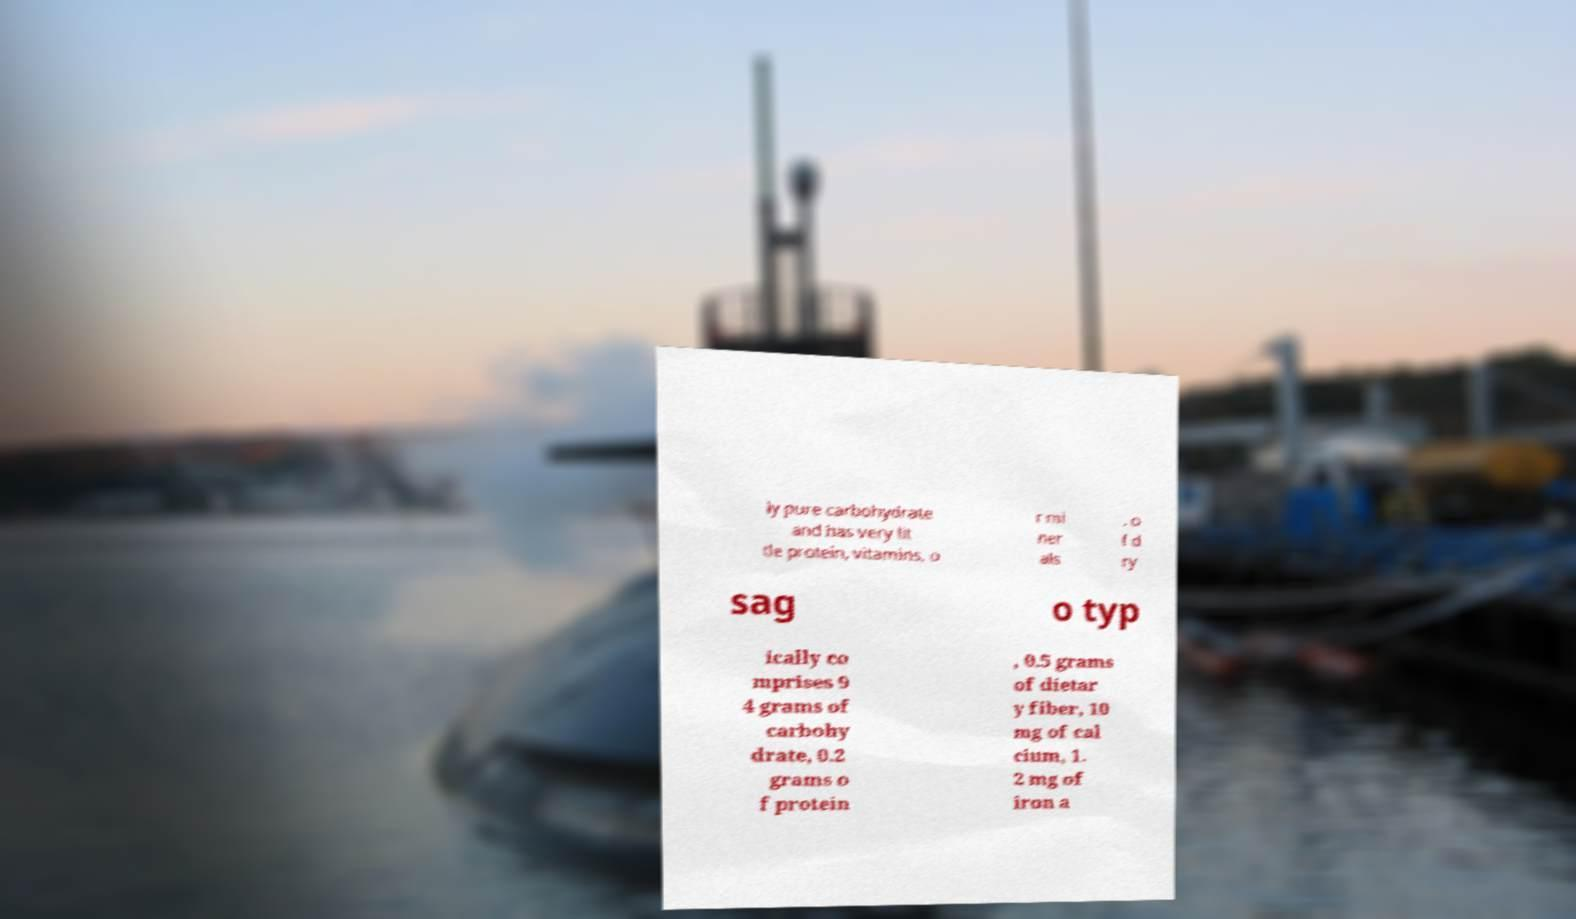I need the written content from this picture converted into text. Can you do that? ly pure carbohydrate and has very lit tle protein, vitamins, o r mi ner als . o f d ry sag o typ ically co mprises 9 4 grams of carbohy drate, 0.2 grams o f protein , 0.5 grams of dietar y fiber, 10 mg of cal cium, 1. 2 mg of iron a 